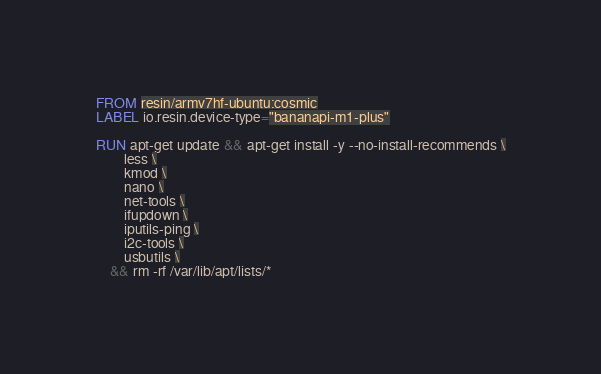Convert code to text. <code><loc_0><loc_0><loc_500><loc_500><_Dockerfile_>FROM resin/armv7hf-ubuntu:cosmic
LABEL io.resin.device-type="bananapi-m1-plus"

RUN apt-get update && apt-get install -y --no-install-recommends \
		less \
		kmod \
		nano \
		net-tools \
		ifupdown \
		iputils-ping \
		i2c-tools \
		usbutils \
	&& rm -rf /var/lib/apt/lists/*</code> 